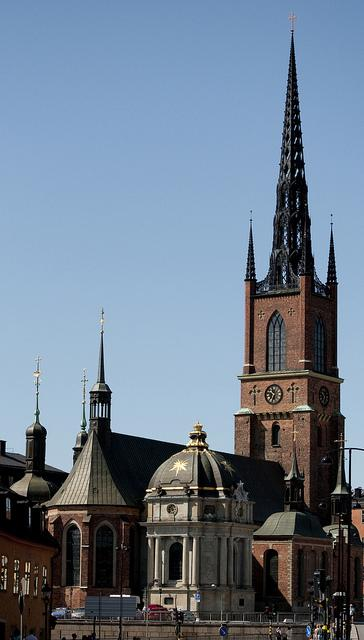What color are the little stars on top of the dome building at the church? gold 